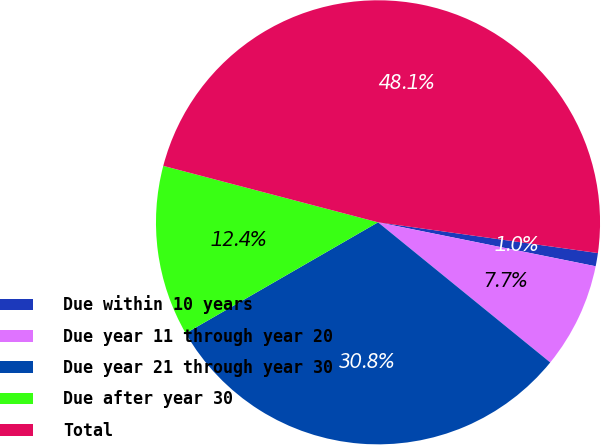Convert chart. <chart><loc_0><loc_0><loc_500><loc_500><pie_chart><fcel>Due within 10 years<fcel>Due year 11 through year 20<fcel>Due year 21 through year 30<fcel>Due after year 30<fcel>Total<nl><fcel>0.96%<fcel>7.7%<fcel>30.8%<fcel>12.42%<fcel>48.12%<nl></chart> 